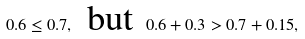Convert formula to latex. <formula><loc_0><loc_0><loc_500><loc_500>0 . 6 \leq 0 . 7 , \, \text { but } \, 0 . 6 + 0 . 3 > 0 . 7 + 0 . 1 5 ,</formula> 